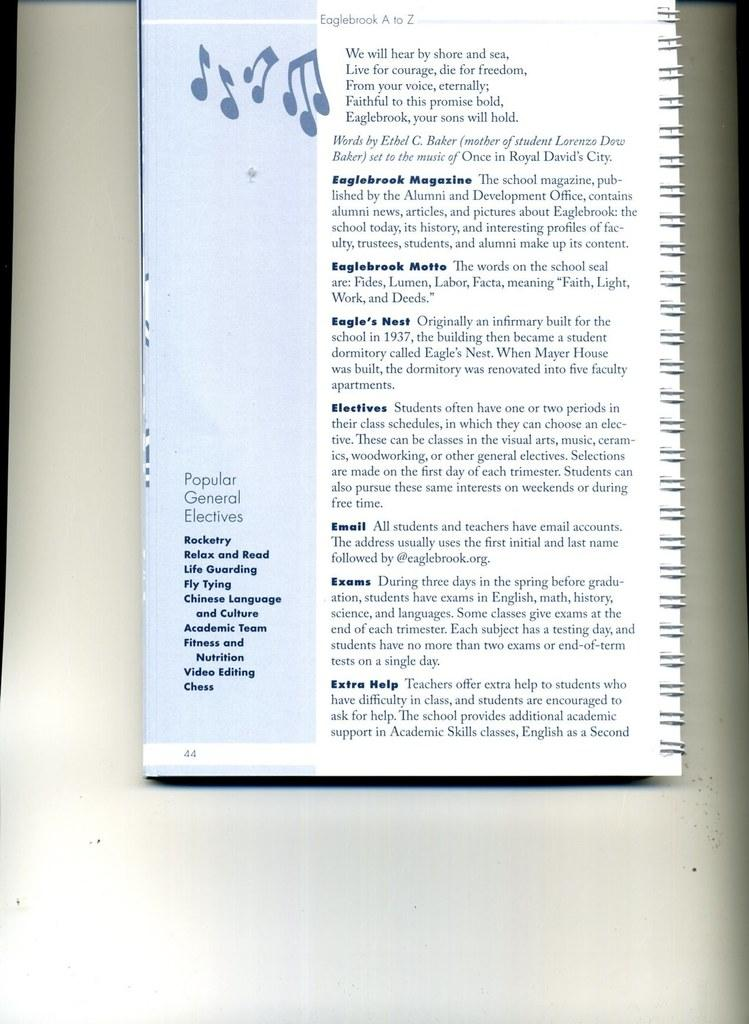<image>
Present a compact description of the photo's key features. a page in a notebook with the words 'eaglebrook a to z' at the top of it 